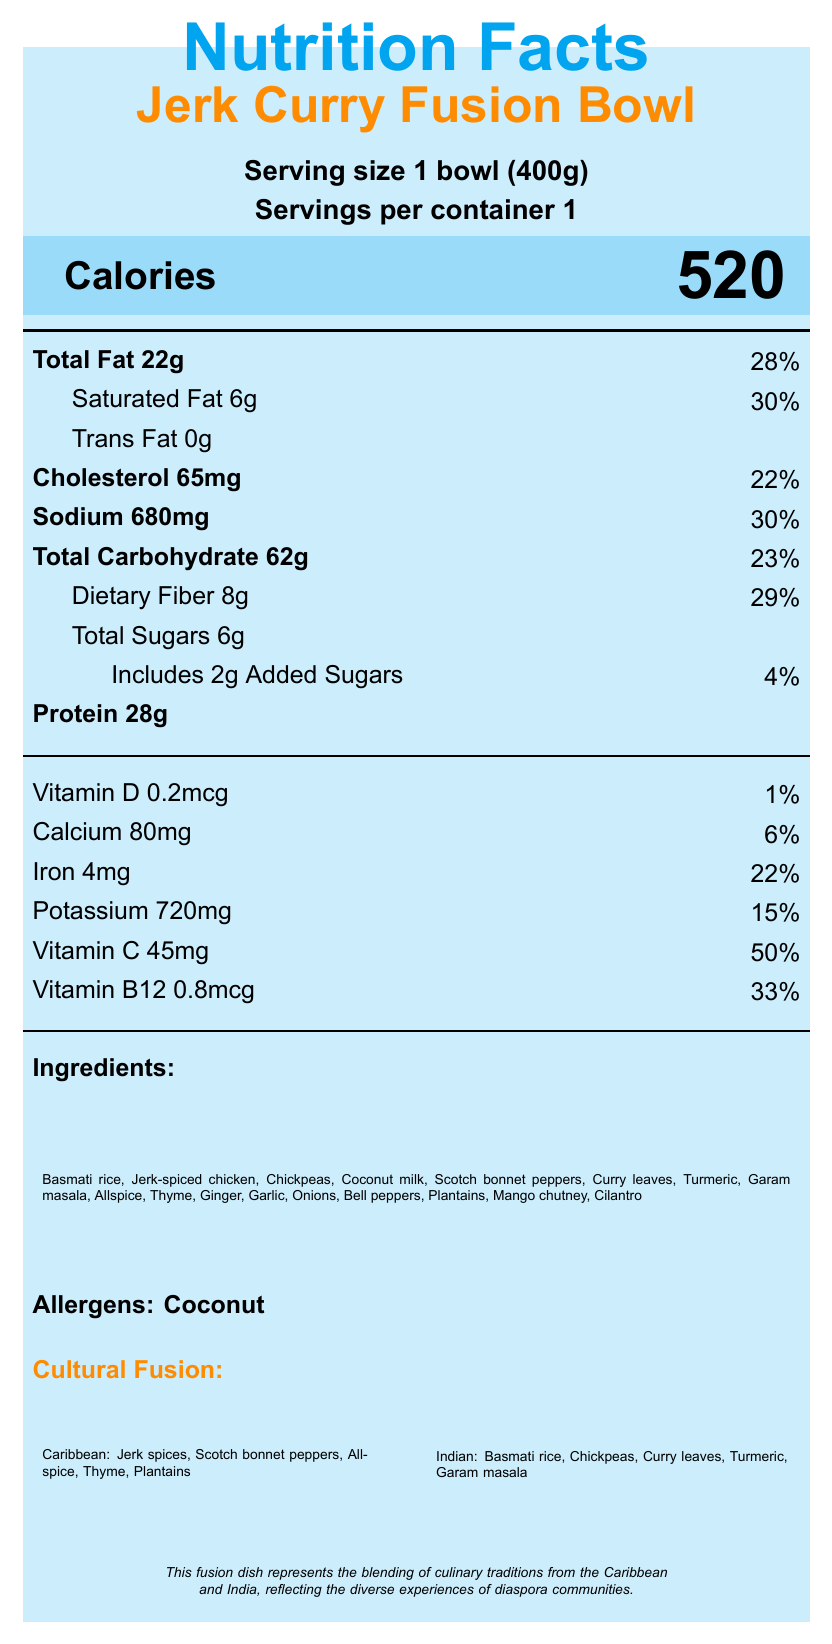what is the serving size? The serving size is indicated at the top of the document as "Serving size 1 bowl (400g)".
Answer: 1 bowl (400g) how many calories are in one serving? The document states the calorie content in a highlighted section: "Calories 520".
Answer: 520 how much total fat is in the bowl? The total fat is listed under the macronutrients table: "Total Fat 22g".
Answer: 22g what percentage of daily value is the dietary fiber content? The dietary fiber daily value percentage is listed as "29%" next to "Dietary Fiber 8g".
Answer: 29% how many grams of protein does the dish contain? The amount of protein is stated as "Protein 28g".
Answer: 28g which allergens are present in this dish? The allergen information is provided at the end of the ingredients list: "Allergens: Coconut".
Answer: Coconut how much vitamin C is in the dish? The amount of Vitamin C is listed under micronutrients: "Vitamin C 45mg".
Answer: 45mg what is one of the fusion elements from the Indian culinary tradition? A. Plantains B. Scotch bonnet peppers C. Basmati rice D. Thyme The document lists "Basmati rice" under the Indian Elements section in cultural insights.
Answer: C what is the daily value percentage of sodium in this dish? The daily value percentage of sodium is listed next to "Sodium 680mg".
Answer: 30% which ingredient is not found in this dish? A. Coconut milk B. Chickpeas C. Cinnamon D. Allspice Cinnamon is not listed among the ingredients, while the others are.
Answer: C is there any added sugar in the dish? The document indicates "Includes 2g Added Sugars" under the carbohydrate section.
Answer: Yes summarize the main purpose of the document. The document includes a title, serving size, servings per container, calorie content, both macronutrients and micronutrients with their daily values, ingredient list, allergens, cultural insights, and a chef's note.
Answer: The document provides detailed nutritional information about the Jerk Curry Fusion Bowl, highlighting its blend of Caribbean and Indian culinary elements, ingredients, allergens, and nutrient contents. how much cholesterol is in the bowl? The cholesterol amount is listed as "Cholesterol 65mg".
Answer: 65mg does the document include information about the source of ingredients? The document mentions in the sustainability note that ingredients are sourced from local Caribbean and Indian farmers.
Answer: Yes are there any details about the anti-inflammatory properties of the ingredients? It is mentioned under nutritional highlights that the dish "Contains anti-inflammatory compounds from turmeric and ginger".
Answer: Yes is there any information about vitamin E content in the dish? The document does not provide any information about vitamin E content.
Answer: Cannot be determined 